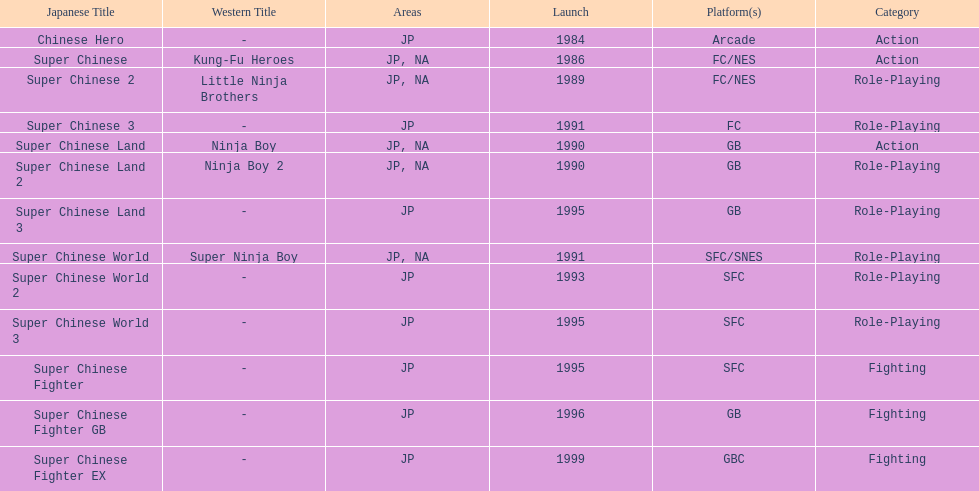The first year a game was released in north america 1986. 